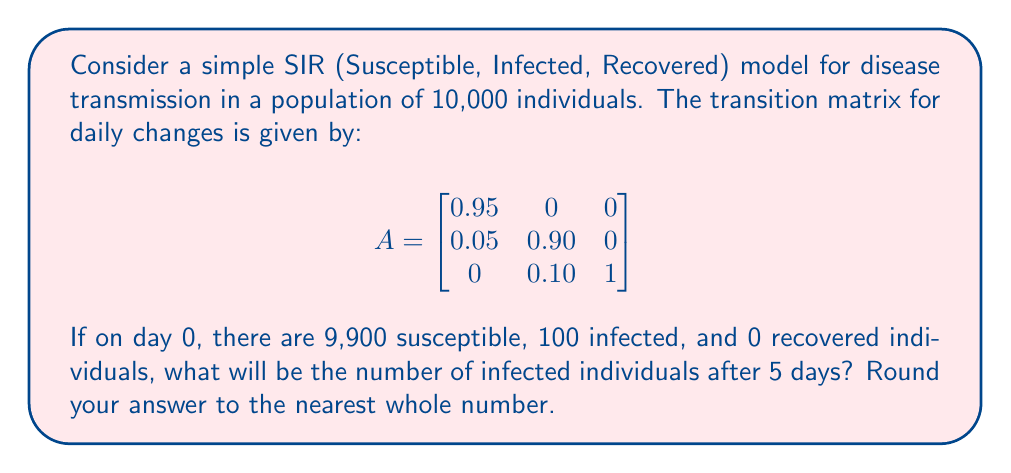Teach me how to tackle this problem. Let's approach this step-by-step:

1) First, we need to represent the initial population as a column vector:

   $$v_0 = \begin{bmatrix}
   9900 \\
   100 \\
   0
   \end{bmatrix}$$

2) To find the population distribution after 5 days, we need to multiply the transition matrix by itself 5 times and then multiply the result by the initial population vector:

   $$v_5 = A^5 \cdot v_0$$

3) Let's calculate $A^5$ using matrix multiplication:

   $$A^2 = \begin{bmatrix}
   0.9025 & 0 & 0 \\
   0.0950 & 0.8100 & 0 \\
   0.0025 & 0.1900 & 1
   \end{bmatrix}$$

   $$A^3 = \begin{bmatrix}
   0.8574 & 0 & 0 \\
   0.1353 & 0.7290 & 0 \\
   0.0073 & 0.2710 & 1
   \end{bmatrix}$$

   $$A^4 = \begin{bmatrix}
   0.8145 & 0 & 0 \\
   0.1681 & 0.6561 & 0 \\
   0.0174 & 0.3439 & 1
   \end{bmatrix}$$

   $$A^5 = \begin{bmatrix}
   0.7738 & 0 & 0 \\
   0.1938 & 0.5905 & 0 \\
   0.0324 & 0.4095 & 1
   \end{bmatrix}$$

4) Now, let's multiply $A^5$ by $v_0$:

   $$v_5 = A^5 \cdot v_0 = \begin{bmatrix}
   0.7738 & 0 & 0 \\
   0.1938 & 0.5905 & 0 \\
   0.0324 & 0.4095 & 1
   \end{bmatrix} \cdot \begin{bmatrix}
   9900 \\
   100 \\
   0
   \end{bmatrix}$$

5) Performing the matrix multiplication:

   $$v_5 = \begin{bmatrix}
   7660.62 \\
   1918.62 \\
   420.76
   \end{bmatrix}$$

6) The number of infected individuals after 5 days is given by the second element of this vector: 1918.62

7) Rounding to the nearest whole number: 1919
Answer: 1919 